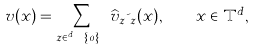Convert formula to latex. <formula><loc_0><loc_0><loc_500><loc_500>v ( x ) = \sum _ { z \in { \mathbb { Z } } ^ { d } \ \{ 0 \} } \widehat { v } _ { z } \psi _ { z } ( x ) , \quad x \in { \mathbb { T } } ^ { d } ,</formula> 